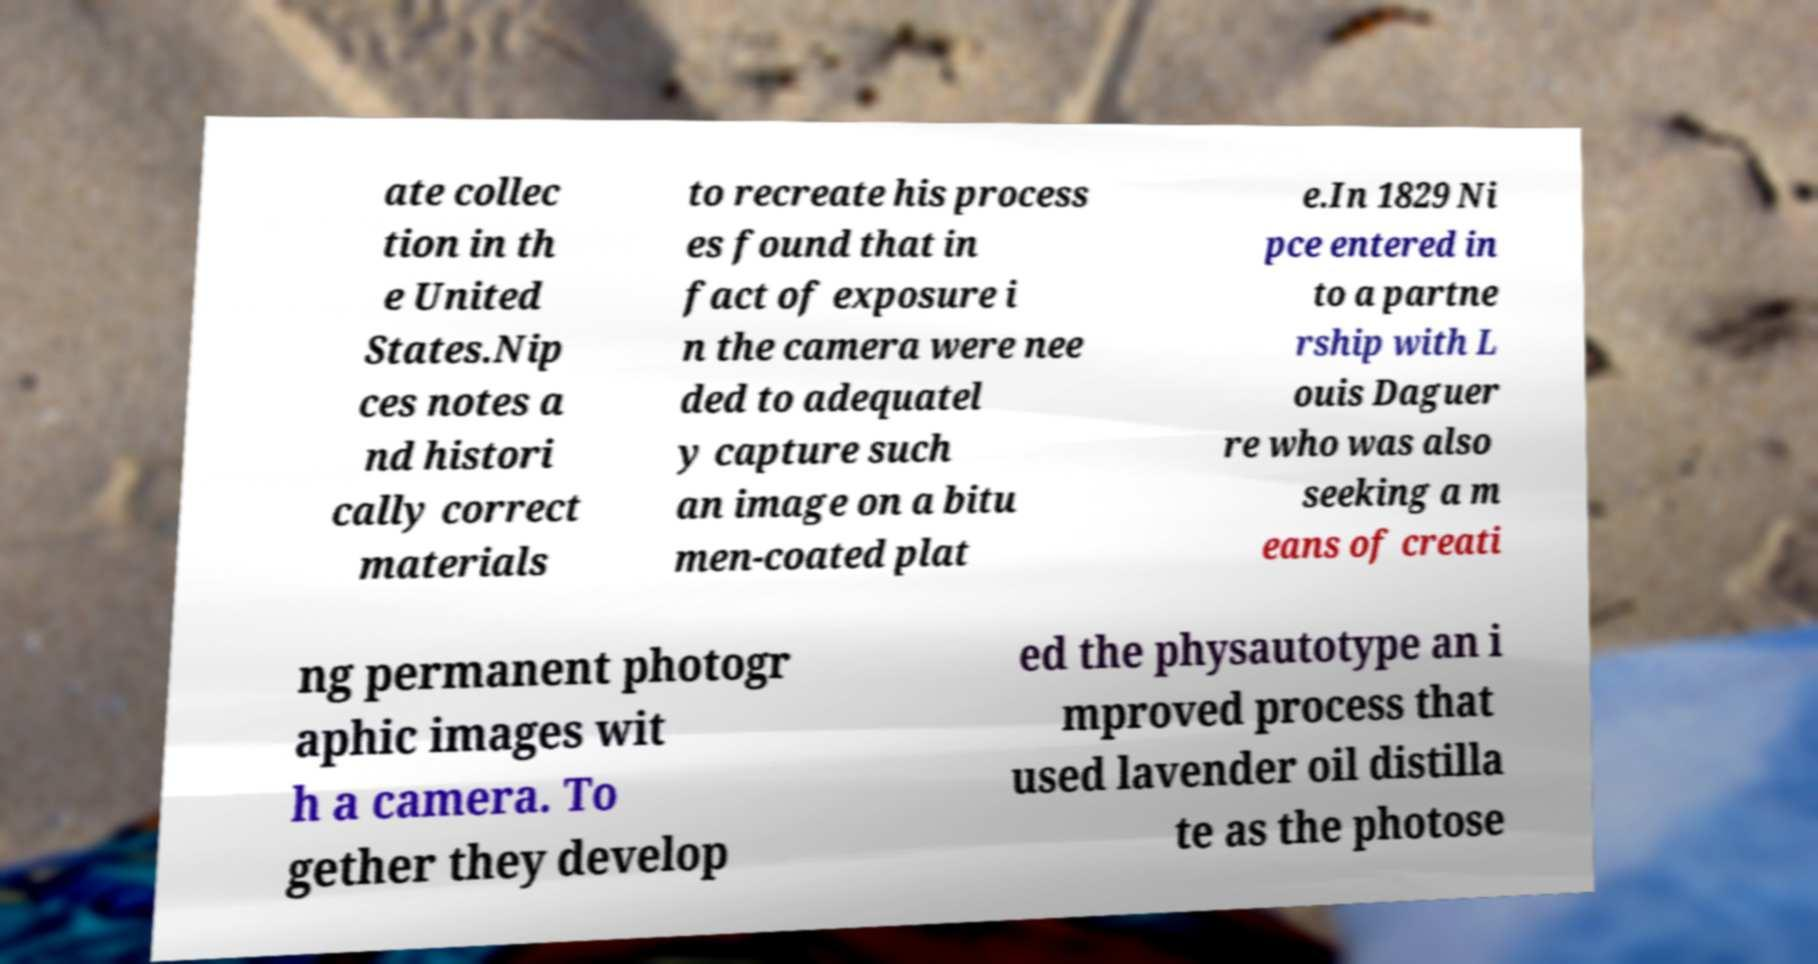Could you assist in decoding the text presented in this image and type it out clearly? ate collec tion in th e United States.Nip ces notes a nd histori cally correct materials to recreate his process es found that in fact of exposure i n the camera were nee ded to adequatel y capture such an image on a bitu men-coated plat e.In 1829 Ni pce entered in to a partne rship with L ouis Daguer re who was also seeking a m eans of creati ng permanent photogr aphic images wit h a camera. To gether they develop ed the physautotype an i mproved process that used lavender oil distilla te as the photose 